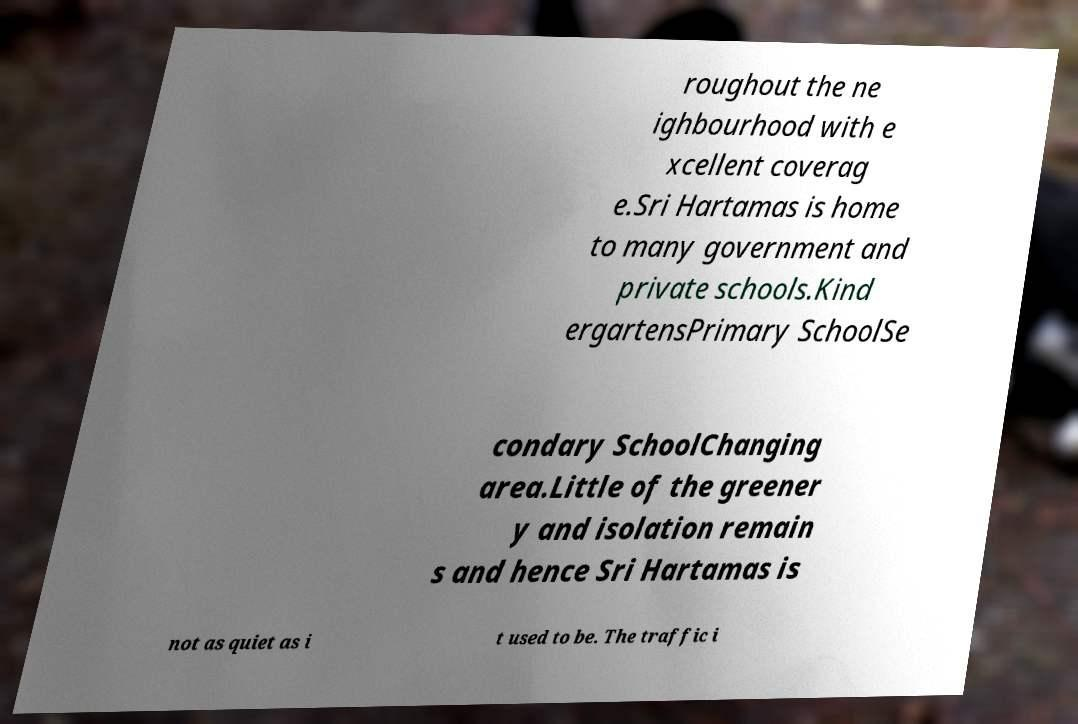Please read and relay the text visible in this image. What does it say? roughout the ne ighbourhood with e xcellent coverag e.Sri Hartamas is home to many government and private schools.Kind ergartensPrimary SchoolSe condary SchoolChanging area.Little of the greener y and isolation remain s and hence Sri Hartamas is not as quiet as i t used to be. The traffic i 